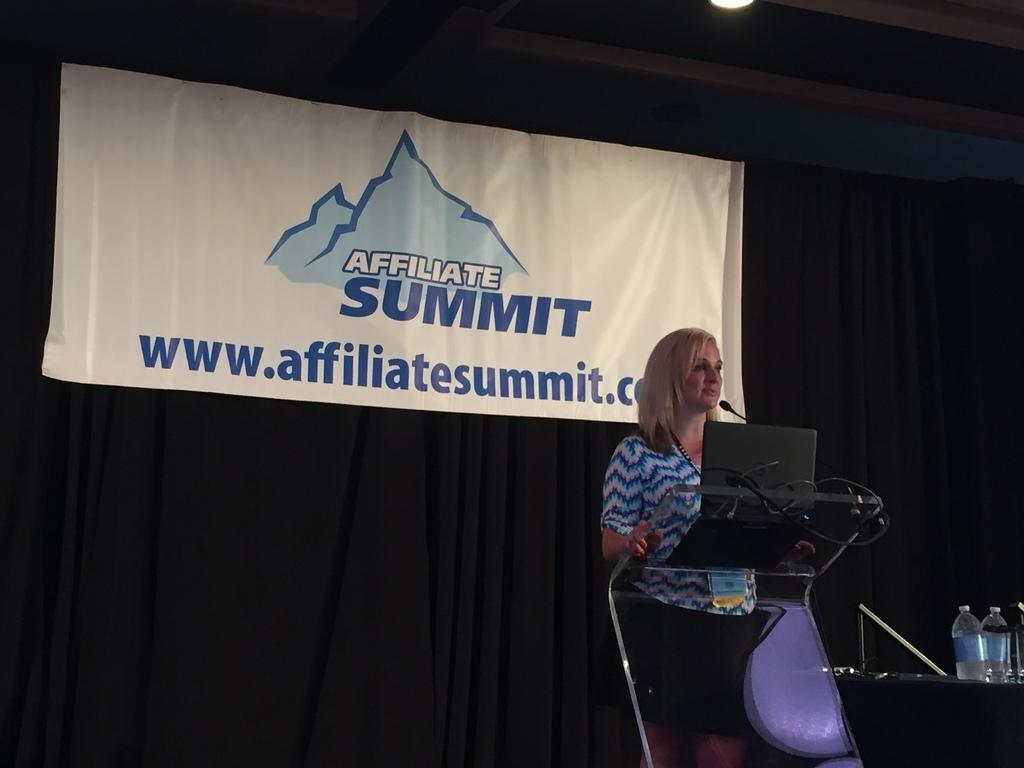<image>
Describe the image concisely. A blonde woman stands at a pedetal speaking in front of a banner proclaiming an Affiliate Summit. 